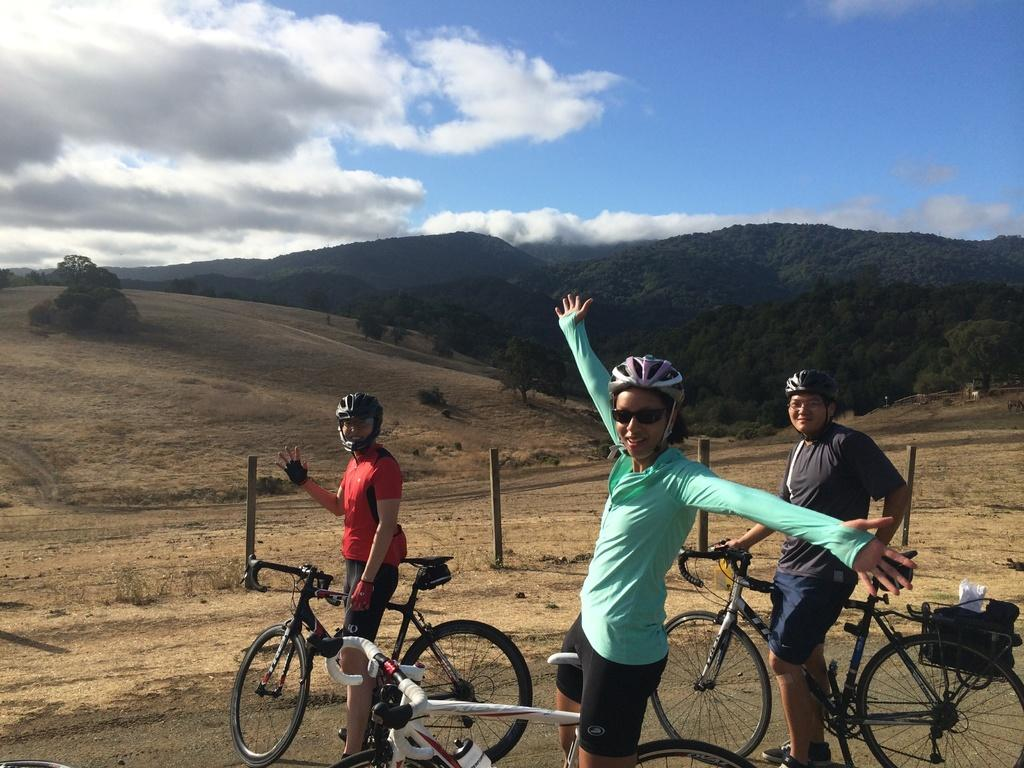How many people are in the image? There are two men and a woman in the image, making a total of three people. What are they doing in the image? They are with a bicycle. How would you describe the sky in the image? The sky is blue and cloudy. Can you identify any other objects or elements in the image? Yes, there is a plant in the image. What type of debt is being discussed by the people in the image? There is no indication in the image that the people are discussing debt or any financial matters. Can you see any snakes in the image? No, there are no snakes present in the image. 